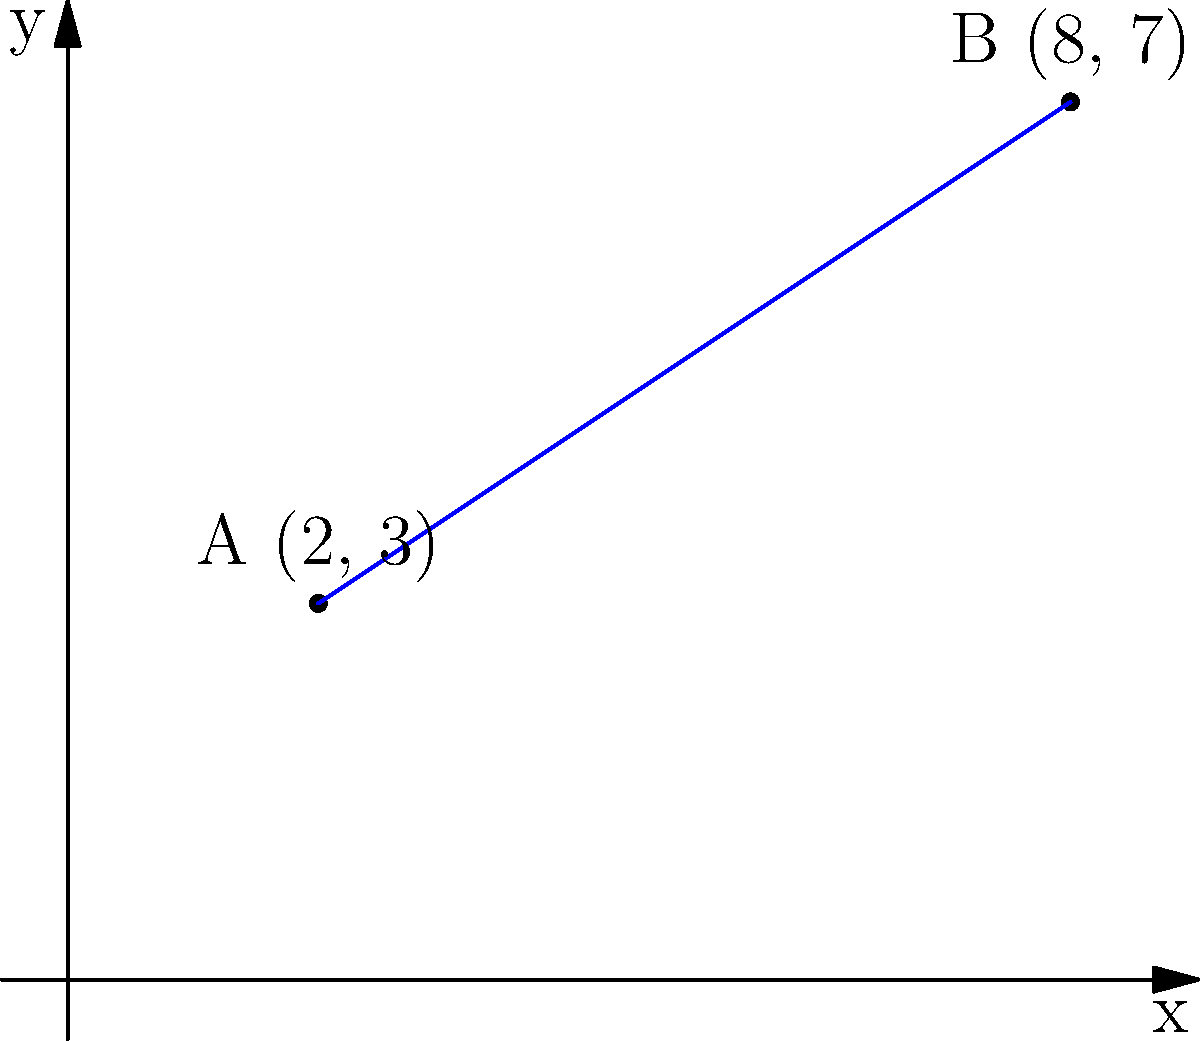Two polling stations in your local constituency are represented as points A(2, 3) and B(8, 7) on a coordinate plane, where each unit represents 100 meters. What is the shortest distance between these two polling stations in meters? To find the shortest distance between two points on a coordinate plane, we can use the distance formula:

$d = \sqrt{(x_2 - x_1)^2 + (y_2 - y_1)^2}$

Where $(x_1, y_1)$ are the coordinates of the first point and $(x_2, y_2)$ are the coordinates of the second point.

Let's follow these steps:

1) Identify the coordinates:
   Point A: $(x_1, y_1) = (2, 3)$
   Point B: $(x_2, y_2) = (8, 7)$

2) Plug these into the distance formula:
   $d = \sqrt{(8 - 2)^2 + (7 - 3)^2}$

3) Simplify inside the parentheses:
   $d = \sqrt{6^2 + 4^2}$

4) Calculate the squares:
   $d = \sqrt{36 + 16}$

5) Add inside the square root:
   $d = \sqrt{52}$

6) Simplify the square root:
   $d = 2\sqrt{13}$

7) This gives us the distance in units. To convert to meters, multiply by 100:
   Distance in meters $= 200\sqrt{13}$

Therefore, the shortest distance between the two polling stations is $200\sqrt{13}$ meters.
Answer: $200\sqrt{13}$ meters 